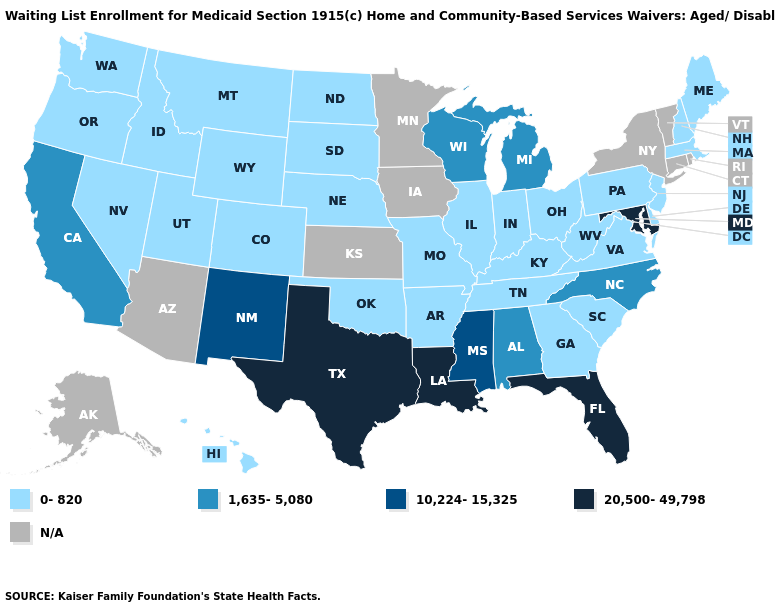Name the states that have a value in the range 1,635-5,080?
Concise answer only. Alabama, California, Michigan, North Carolina, Wisconsin. Name the states that have a value in the range 20,500-49,798?
Keep it brief. Florida, Louisiana, Maryland, Texas. Name the states that have a value in the range 1,635-5,080?
Give a very brief answer. Alabama, California, Michigan, North Carolina, Wisconsin. Which states have the highest value in the USA?
Give a very brief answer. Florida, Louisiana, Maryland, Texas. How many symbols are there in the legend?
Write a very short answer. 5. Which states have the lowest value in the South?
Short answer required. Arkansas, Delaware, Georgia, Kentucky, Oklahoma, South Carolina, Tennessee, Virginia, West Virginia. What is the highest value in states that border Kentucky?
Give a very brief answer. 0-820. What is the value of Kentucky?
Concise answer only. 0-820. What is the lowest value in the MidWest?
Concise answer only. 0-820. Which states have the lowest value in the USA?
Short answer required. Arkansas, Colorado, Delaware, Georgia, Hawaii, Idaho, Illinois, Indiana, Kentucky, Maine, Massachusetts, Missouri, Montana, Nebraska, Nevada, New Hampshire, New Jersey, North Dakota, Ohio, Oklahoma, Oregon, Pennsylvania, South Carolina, South Dakota, Tennessee, Utah, Virginia, Washington, West Virginia, Wyoming. What is the value of Michigan?
Answer briefly. 1,635-5,080. Does Pennsylvania have the lowest value in the USA?
Quick response, please. Yes. What is the value of California?
Concise answer only. 1,635-5,080. Is the legend a continuous bar?
Quick response, please. No. 